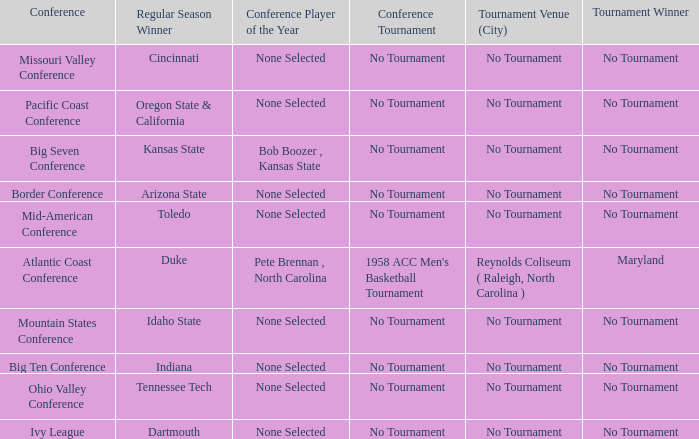Who won the regular season when Maryland won the tournament? Duke. 